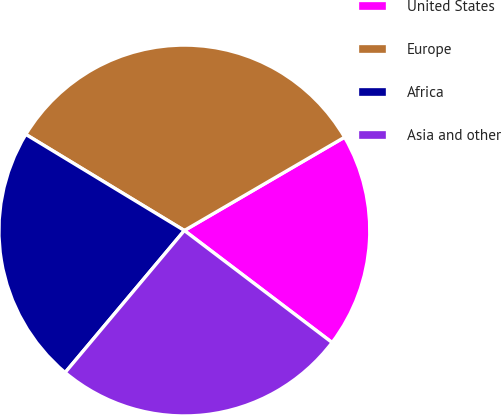Convert chart to OTSL. <chart><loc_0><loc_0><loc_500><loc_500><pie_chart><fcel>United States<fcel>Europe<fcel>Africa<fcel>Asia and other<nl><fcel>18.72%<fcel>32.93%<fcel>22.56%<fcel>25.79%<nl></chart> 